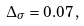Convert formula to latex. <formula><loc_0><loc_0><loc_500><loc_500>\Delta _ { \sigma } = 0 . 0 7 \, ,</formula> 